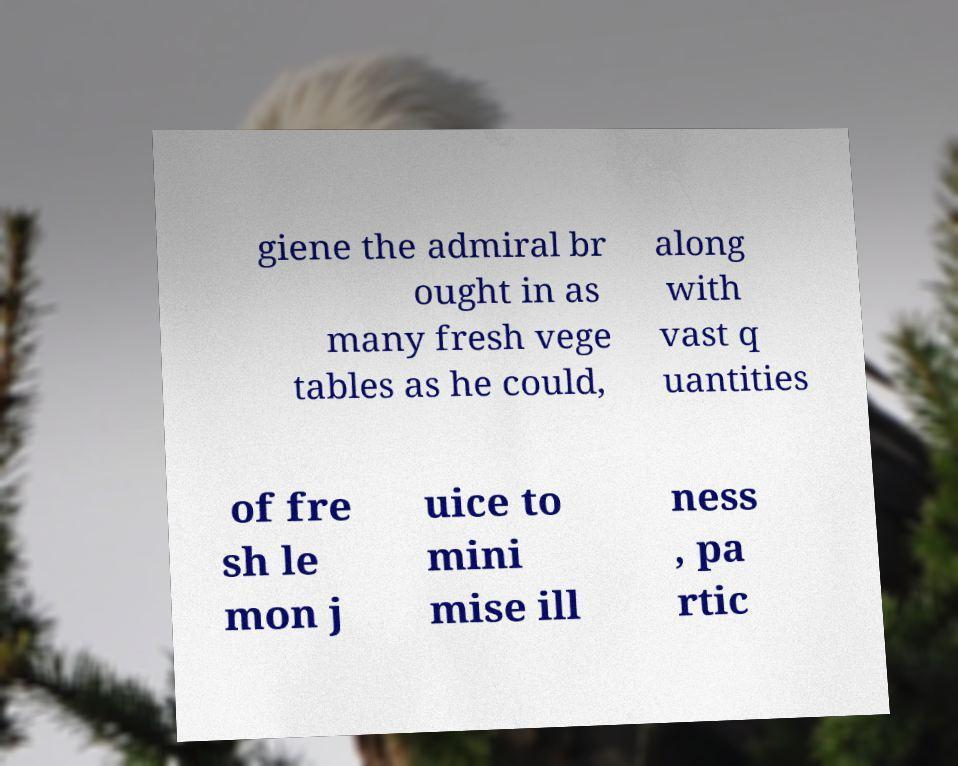For documentation purposes, I need the text within this image transcribed. Could you provide that? giene the admiral br ought in as many fresh vege tables as he could, along with vast q uantities of fre sh le mon j uice to mini mise ill ness , pa rtic 